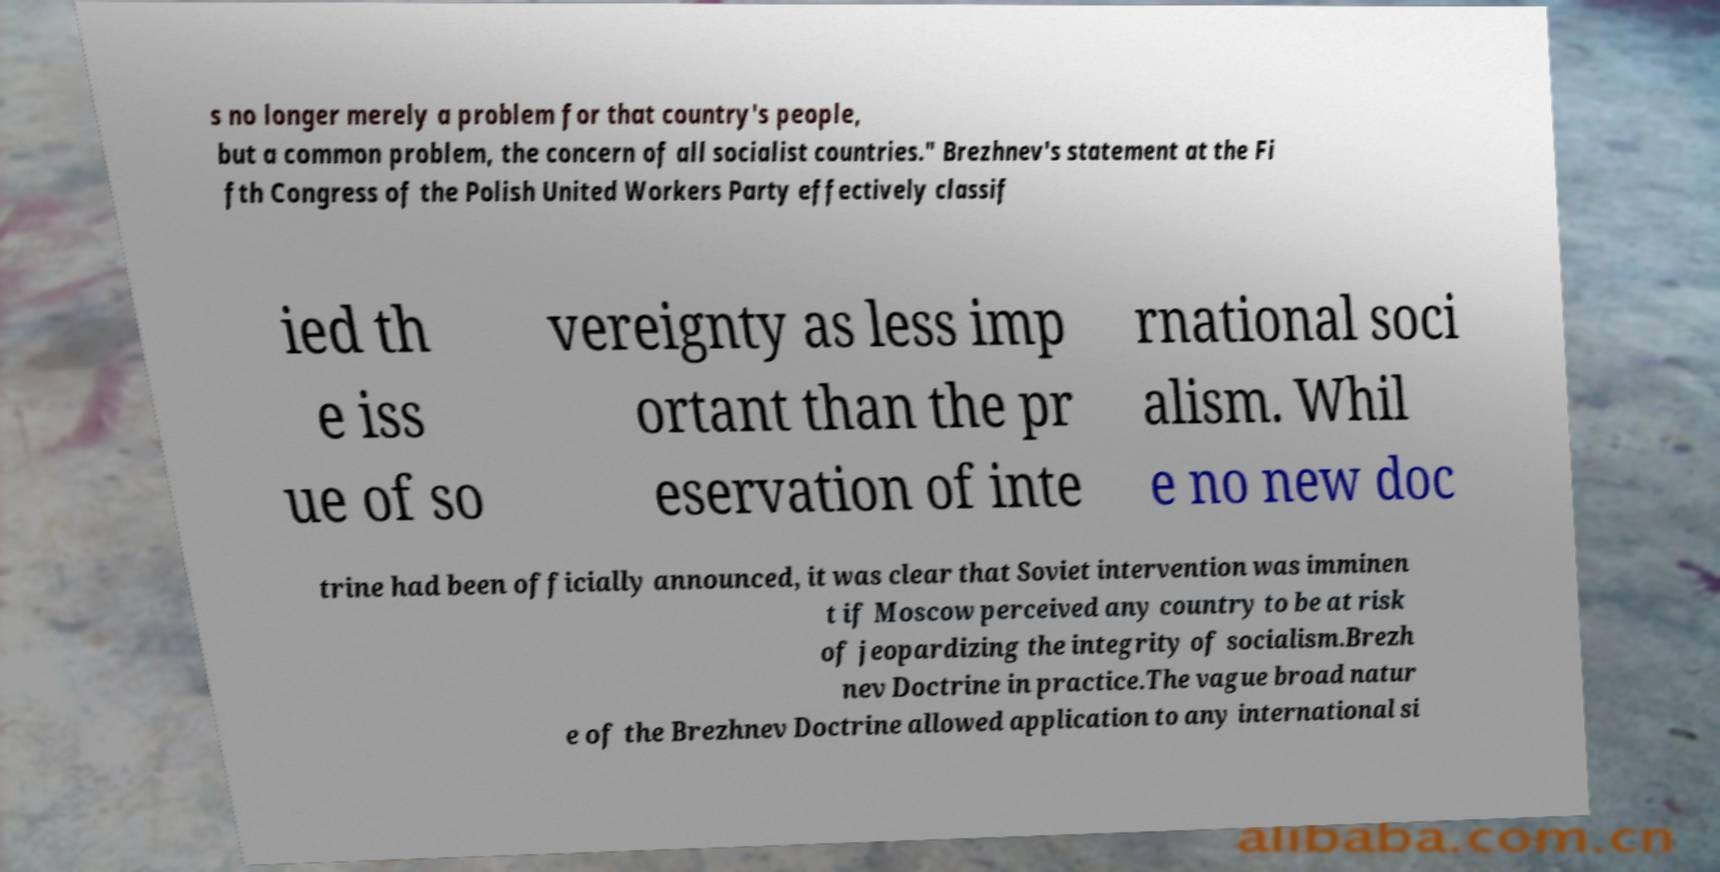I need the written content from this picture converted into text. Can you do that? s no longer merely a problem for that country's people, but a common problem, the concern of all socialist countries." Brezhnev's statement at the Fi fth Congress of the Polish United Workers Party effectively classif ied th e iss ue of so vereignty as less imp ortant than the pr eservation of inte rnational soci alism. Whil e no new doc trine had been officially announced, it was clear that Soviet intervention was imminen t if Moscow perceived any country to be at risk of jeopardizing the integrity of socialism.Brezh nev Doctrine in practice.The vague broad natur e of the Brezhnev Doctrine allowed application to any international si 